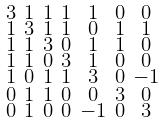Convert formula to latex. <formula><loc_0><loc_0><loc_500><loc_500>\begin{smallmatrix} 3 & 1 & 1 & 1 & 1 & 0 & 0 \\ 1 & 3 & 1 & 1 & 0 & 1 & 1 \\ 1 & 1 & 3 & 0 & 1 & 1 & 0 \\ 1 & 1 & 0 & 3 & 1 & 0 & 0 \\ 1 & 0 & 1 & 1 & 3 & 0 & - 1 \\ 0 & 1 & 1 & 0 & 0 & 3 & 0 \\ 0 & 1 & 0 & 0 & - 1 & 0 & 3 \end{smallmatrix}</formula> 